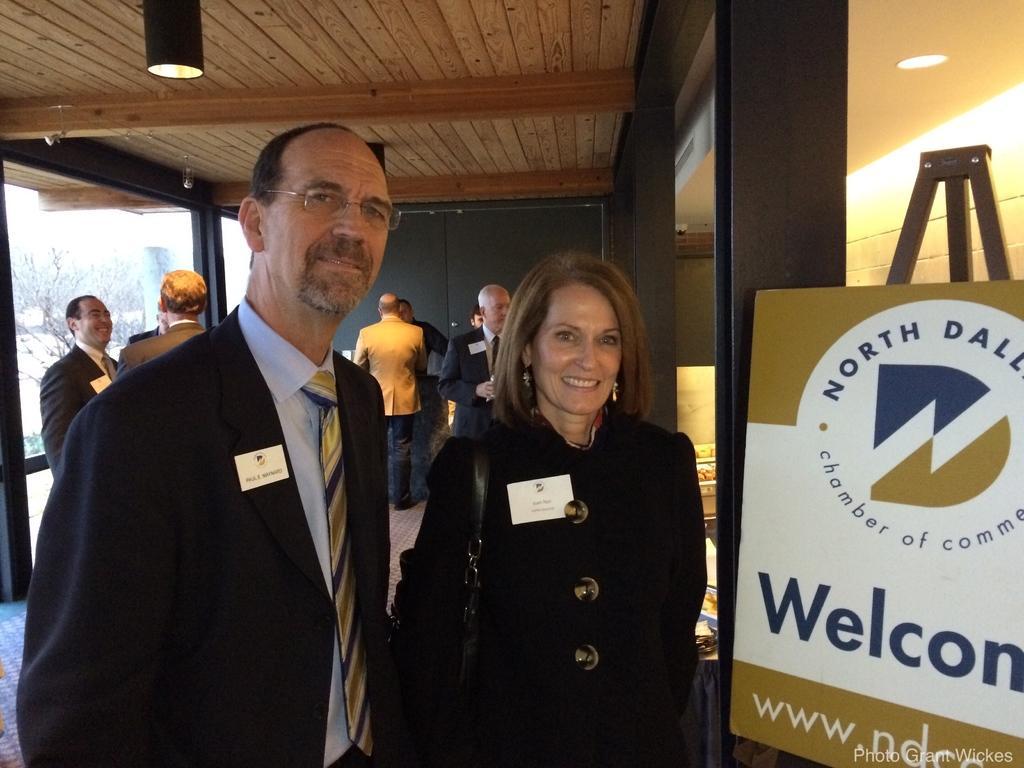In one or two sentences, can you explain what this image depicts? In this image there is a lady and a man standing, on the right side there is a board, on that board there is some text, in the bottom right there is some text, in the background there are people standing and there are pillars, at the top there is a wooden ceiling and lights. 